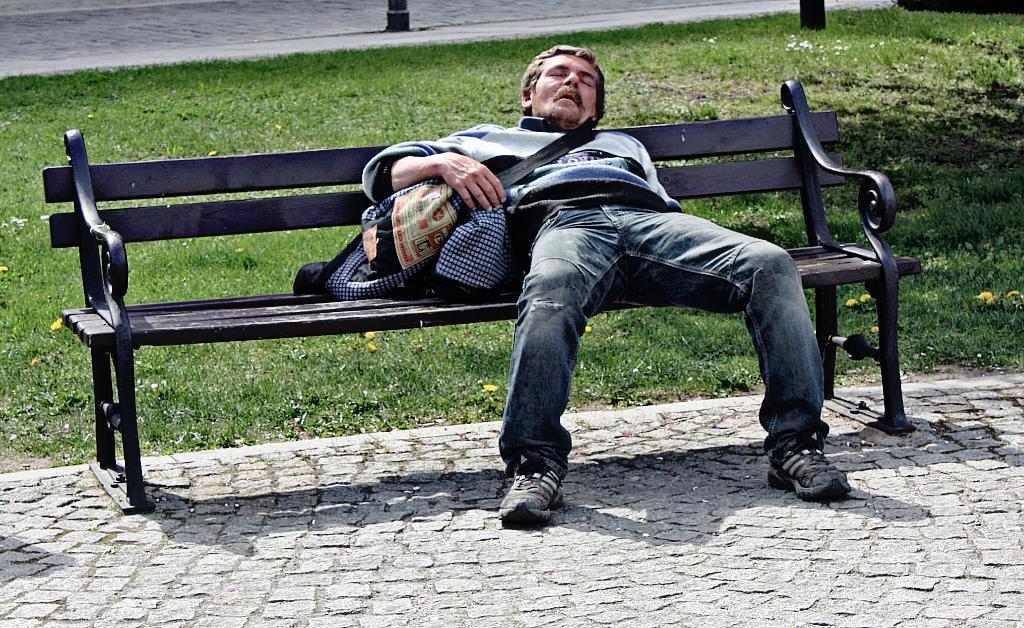In one or two sentences, can you explain what this image depicts? In this picture i could see a person laying on the bench which is black in color. He is holding some bags in his right hand and in the back ground there is grass on the ground. 